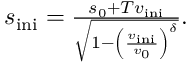Convert formula to latex. <formula><loc_0><loc_0><loc_500><loc_500>\begin{array} { r } { s _ { i n i } = \frac { s _ { 0 } + T v _ { i n i } } { \sqrt { 1 - \left ( \frac { v _ { i n i } } { v _ { 0 } } \right ) ^ { \delta } } } . } \end{array}</formula> 